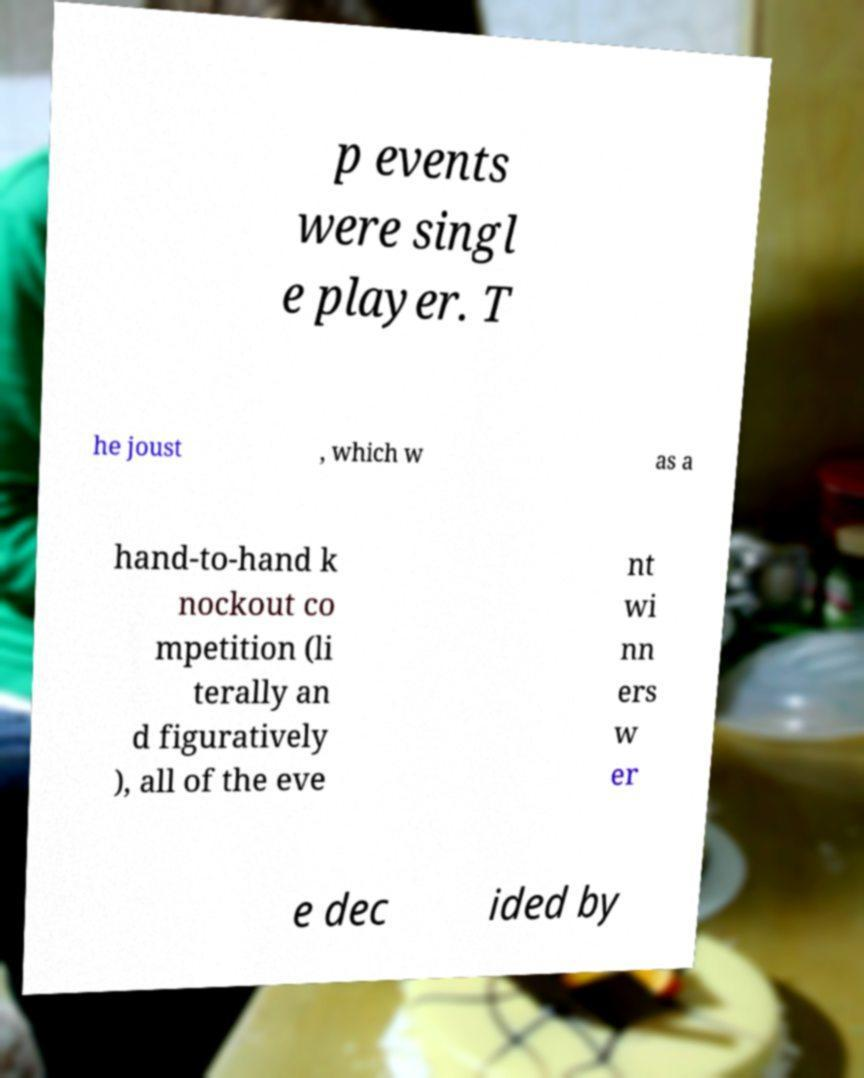Please read and relay the text visible in this image. What does it say? p events were singl e player. T he joust , which w as a hand-to-hand k nockout co mpetition (li terally an d figuratively ), all of the eve nt wi nn ers w er e dec ided by 